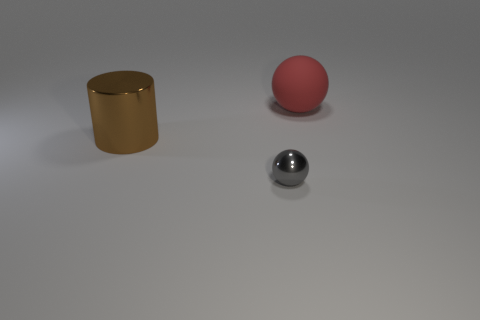Add 2 large things. How many objects exist? 5 Subtract all balls. How many objects are left? 1 Add 3 large things. How many large things are left? 5 Add 2 tiny green matte blocks. How many tiny green matte blocks exist? 2 Subtract 1 red balls. How many objects are left? 2 Subtract all big brown cylinders. Subtract all brown cylinders. How many objects are left? 1 